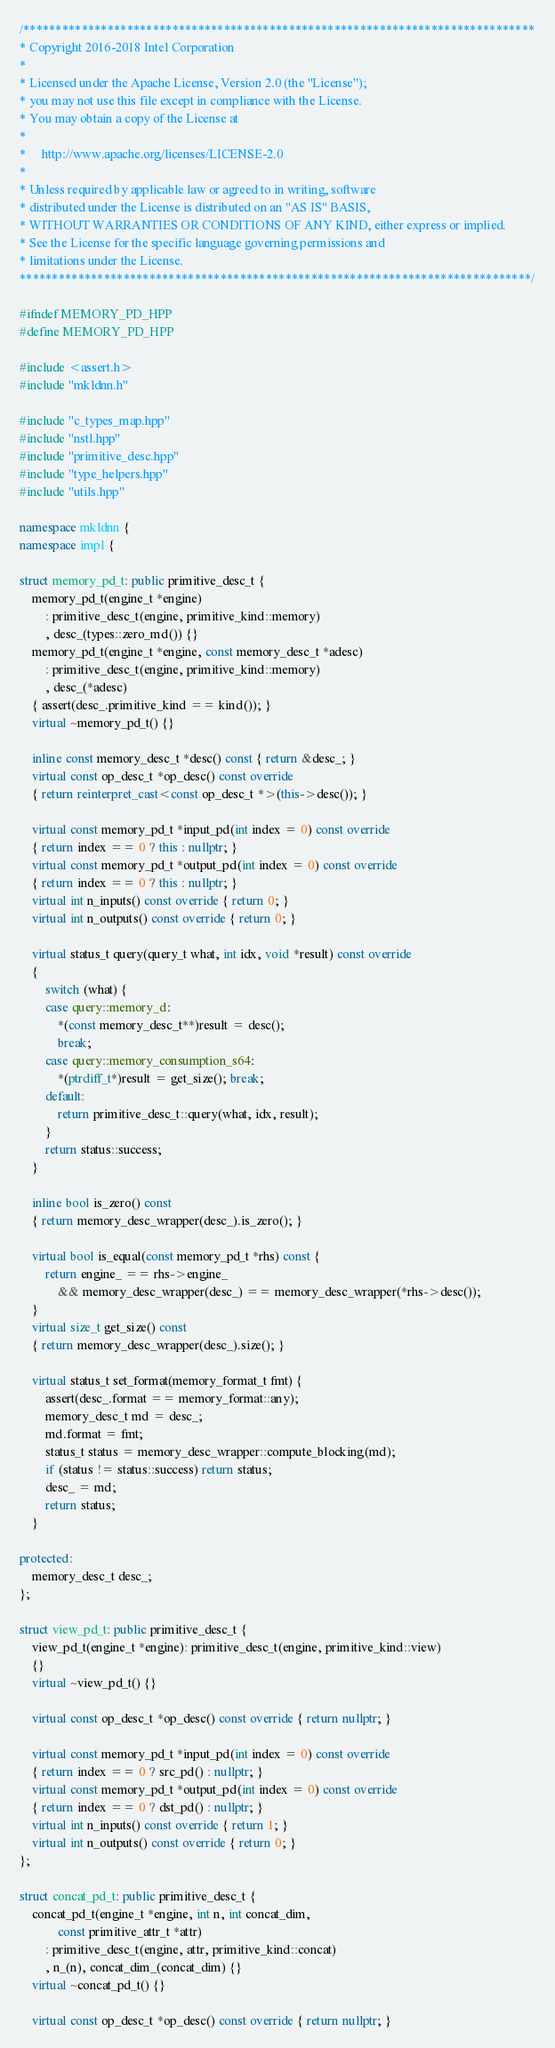Convert code to text. <code><loc_0><loc_0><loc_500><loc_500><_C++_>/*******************************************************************************
* Copyright 2016-2018 Intel Corporation
*
* Licensed under the Apache License, Version 2.0 (the "License");
* you may not use this file except in compliance with the License.
* You may obtain a copy of the License at
*
*     http://www.apache.org/licenses/LICENSE-2.0
*
* Unless required by applicable law or agreed to in writing, software
* distributed under the License is distributed on an "AS IS" BASIS,
* WITHOUT WARRANTIES OR CONDITIONS OF ANY KIND, either express or implied.
* See the License for the specific language governing permissions and
* limitations under the License.
*******************************************************************************/

#ifndef MEMORY_PD_HPP
#define MEMORY_PD_HPP

#include <assert.h>
#include "mkldnn.h"

#include "c_types_map.hpp"
#include "nstl.hpp"
#include "primitive_desc.hpp"
#include "type_helpers.hpp"
#include "utils.hpp"

namespace mkldnn {
namespace impl {

struct memory_pd_t: public primitive_desc_t {
    memory_pd_t(engine_t *engine)
        : primitive_desc_t(engine, primitive_kind::memory)
        , desc_(types::zero_md()) {}
    memory_pd_t(engine_t *engine, const memory_desc_t *adesc)
        : primitive_desc_t(engine, primitive_kind::memory)
        , desc_(*adesc)
    { assert(desc_.primitive_kind == kind()); }
    virtual ~memory_pd_t() {}

    inline const memory_desc_t *desc() const { return &desc_; }
    virtual const op_desc_t *op_desc() const override
    { return reinterpret_cast<const op_desc_t *>(this->desc()); }

    virtual const memory_pd_t *input_pd(int index = 0) const override
    { return index == 0 ? this : nullptr; }
    virtual const memory_pd_t *output_pd(int index = 0) const override
    { return index == 0 ? this : nullptr; }
    virtual int n_inputs() const override { return 0; }
    virtual int n_outputs() const override { return 0; }

    virtual status_t query(query_t what, int idx, void *result) const override
    {
        switch (what) {
        case query::memory_d:
            *(const memory_desc_t**)result = desc();
            break;
        case query::memory_consumption_s64:
            *(ptrdiff_t*)result = get_size(); break;
        default:
            return primitive_desc_t::query(what, idx, result);
        }
        return status::success;
    }

    inline bool is_zero() const
    { return memory_desc_wrapper(desc_).is_zero(); }

    virtual bool is_equal(const memory_pd_t *rhs) const {
        return engine_ == rhs->engine_
            && memory_desc_wrapper(desc_) == memory_desc_wrapper(*rhs->desc());
    }
    virtual size_t get_size() const
    { return memory_desc_wrapper(desc_).size(); }

    virtual status_t set_format(memory_format_t fmt) {
        assert(desc_.format == memory_format::any);
        memory_desc_t md = desc_;
        md.format = fmt;
        status_t status = memory_desc_wrapper::compute_blocking(md);
        if (status != status::success) return status;
        desc_ = md;
        return status;
    }

protected:
    memory_desc_t desc_;
};

struct view_pd_t: public primitive_desc_t {
    view_pd_t(engine_t *engine): primitive_desc_t(engine, primitive_kind::view)
    {}
    virtual ~view_pd_t() {}

    virtual const op_desc_t *op_desc() const override { return nullptr; }

    virtual const memory_pd_t *input_pd(int index = 0) const override
    { return index == 0 ? src_pd() : nullptr; }
    virtual const memory_pd_t *output_pd(int index = 0) const override
    { return index == 0 ? dst_pd() : nullptr; }
    virtual int n_inputs() const override { return 1; }
    virtual int n_outputs() const override { return 0; }
};

struct concat_pd_t: public primitive_desc_t {
    concat_pd_t(engine_t *engine, int n, int concat_dim,
            const primitive_attr_t *attr)
        : primitive_desc_t(engine, attr, primitive_kind::concat)
        , n_(n), concat_dim_(concat_dim) {}
    virtual ~concat_pd_t() {}

    virtual const op_desc_t *op_desc() const override { return nullptr; }</code> 